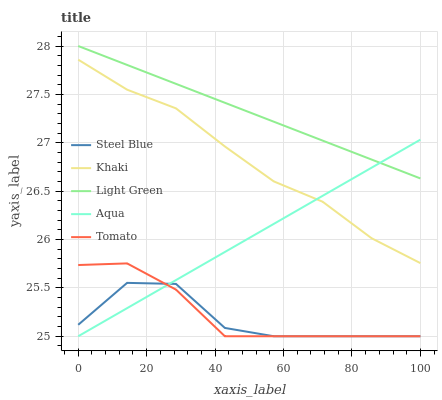Does Steel Blue have the minimum area under the curve?
Answer yes or no. Yes. Does Light Green have the maximum area under the curve?
Answer yes or no. Yes. Does Khaki have the minimum area under the curve?
Answer yes or no. No. Does Khaki have the maximum area under the curve?
Answer yes or no. No. Is Aqua the smoothest?
Answer yes or no. Yes. Is Steel Blue the roughest?
Answer yes or no. Yes. Is Khaki the smoothest?
Answer yes or no. No. Is Khaki the roughest?
Answer yes or no. No. Does Khaki have the lowest value?
Answer yes or no. No. Does Khaki have the highest value?
Answer yes or no. No. Is Khaki less than Light Green?
Answer yes or no. Yes. Is Light Green greater than Tomato?
Answer yes or no. Yes. Does Khaki intersect Light Green?
Answer yes or no. No. 